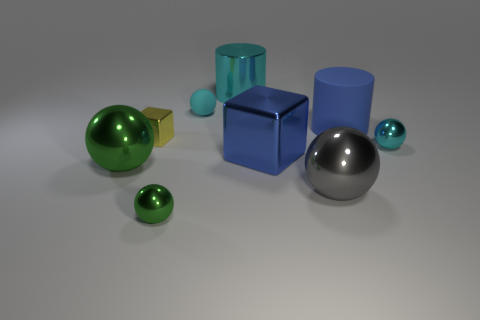Subtract 1 balls. How many balls are left? 4 Subtract all gray spheres. Subtract all purple blocks. How many spheres are left? 4 Add 1 gray spheres. How many objects exist? 10 Subtract all balls. How many objects are left? 4 Add 9 big red things. How many big red things exist? 9 Subtract 1 blue blocks. How many objects are left? 8 Subtract all small green shiny things. Subtract all tiny yellow shiny cubes. How many objects are left? 7 Add 6 tiny metallic cubes. How many tiny metallic cubes are left? 7 